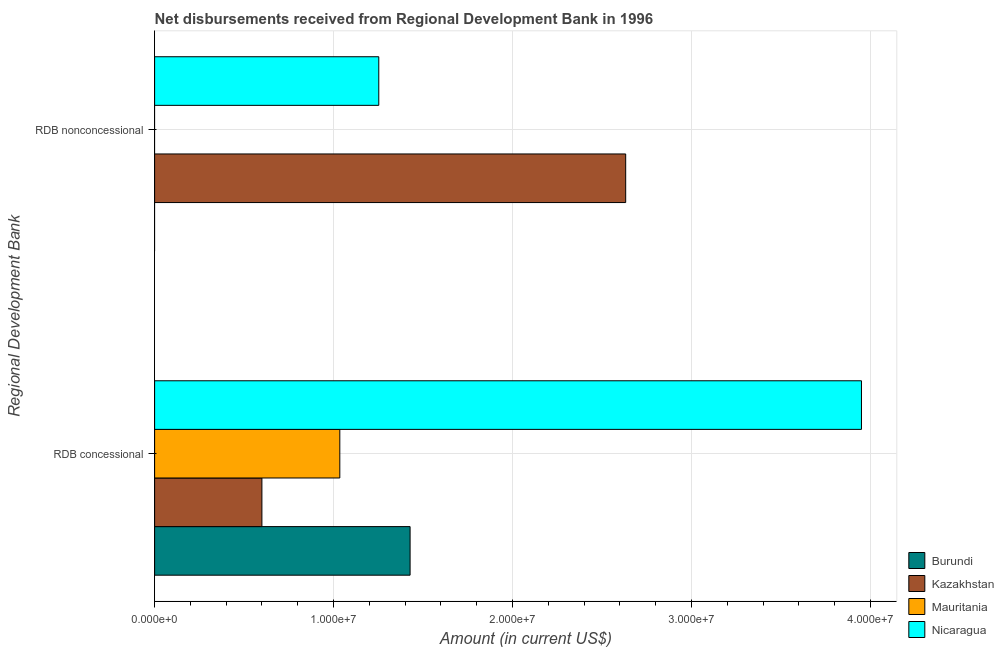How many different coloured bars are there?
Offer a terse response. 4. Are the number of bars on each tick of the Y-axis equal?
Your answer should be very brief. No. What is the label of the 2nd group of bars from the top?
Give a very brief answer. RDB concessional. What is the net concessional disbursements from rdb in Nicaragua?
Give a very brief answer. 3.95e+07. Across all countries, what is the maximum net non concessional disbursements from rdb?
Your answer should be very brief. 2.63e+07. In which country was the net non concessional disbursements from rdb maximum?
Offer a very short reply. Kazakhstan. What is the total net concessional disbursements from rdb in the graph?
Provide a succinct answer. 7.01e+07. What is the difference between the net concessional disbursements from rdb in Kazakhstan and that in Mauritania?
Offer a terse response. -4.35e+06. What is the difference between the net concessional disbursements from rdb in Mauritania and the net non concessional disbursements from rdb in Nicaragua?
Your response must be concise. -2.18e+06. What is the average net non concessional disbursements from rdb per country?
Your response must be concise. 9.71e+06. What is the difference between the net non concessional disbursements from rdb and net concessional disbursements from rdb in Nicaragua?
Make the answer very short. -2.70e+07. What is the ratio of the net concessional disbursements from rdb in Nicaragua to that in Burundi?
Your answer should be compact. 2.77. Are all the bars in the graph horizontal?
Ensure brevity in your answer.  Yes. How many countries are there in the graph?
Provide a succinct answer. 4. What is the difference between two consecutive major ticks on the X-axis?
Your answer should be very brief. 1.00e+07. Are the values on the major ticks of X-axis written in scientific E-notation?
Your response must be concise. Yes. Does the graph contain grids?
Provide a short and direct response. Yes. How many legend labels are there?
Keep it short and to the point. 4. How are the legend labels stacked?
Provide a succinct answer. Vertical. What is the title of the graph?
Your answer should be very brief. Net disbursements received from Regional Development Bank in 1996. What is the label or title of the Y-axis?
Your response must be concise. Regional Development Bank. What is the Amount (in current US$) of Burundi in RDB concessional?
Make the answer very short. 1.43e+07. What is the Amount (in current US$) of Kazakhstan in RDB concessional?
Keep it short and to the point. 6.00e+06. What is the Amount (in current US$) of Mauritania in RDB concessional?
Provide a short and direct response. 1.04e+07. What is the Amount (in current US$) of Nicaragua in RDB concessional?
Your answer should be very brief. 3.95e+07. What is the Amount (in current US$) in Burundi in RDB nonconcessional?
Your answer should be very brief. 0. What is the Amount (in current US$) of Kazakhstan in RDB nonconcessional?
Offer a terse response. 2.63e+07. What is the Amount (in current US$) in Nicaragua in RDB nonconcessional?
Ensure brevity in your answer.  1.25e+07. Across all Regional Development Bank, what is the maximum Amount (in current US$) of Burundi?
Provide a succinct answer. 1.43e+07. Across all Regional Development Bank, what is the maximum Amount (in current US$) in Kazakhstan?
Your response must be concise. 2.63e+07. Across all Regional Development Bank, what is the maximum Amount (in current US$) in Mauritania?
Your response must be concise. 1.04e+07. Across all Regional Development Bank, what is the maximum Amount (in current US$) in Nicaragua?
Offer a very short reply. 3.95e+07. Across all Regional Development Bank, what is the minimum Amount (in current US$) in Burundi?
Your answer should be compact. 0. Across all Regional Development Bank, what is the minimum Amount (in current US$) of Kazakhstan?
Provide a short and direct response. 6.00e+06. Across all Regional Development Bank, what is the minimum Amount (in current US$) in Mauritania?
Offer a very short reply. 0. Across all Regional Development Bank, what is the minimum Amount (in current US$) of Nicaragua?
Offer a terse response. 1.25e+07. What is the total Amount (in current US$) of Burundi in the graph?
Offer a very short reply. 1.43e+07. What is the total Amount (in current US$) in Kazakhstan in the graph?
Your answer should be very brief. 3.23e+07. What is the total Amount (in current US$) of Mauritania in the graph?
Your answer should be compact. 1.04e+07. What is the total Amount (in current US$) of Nicaragua in the graph?
Give a very brief answer. 5.20e+07. What is the difference between the Amount (in current US$) in Kazakhstan in RDB concessional and that in RDB nonconcessional?
Offer a very short reply. -2.03e+07. What is the difference between the Amount (in current US$) of Nicaragua in RDB concessional and that in RDB nonconcessional?
Ensure brevity in your answer.  2.70e+07. What is the difference between the Amount (in current US$) of Burundi in RDB concessional and the Amount (in current US$) of Kazakhstan in RDB nonconcessional?
Ensure brevity in your answer.  -1.20e+07. What is the difference between the Amount (in current US$) of Burundi in RDB concessional and the Amount (in current US$) of Nicaragua in RDB nonconcessional?
Make the answer very short. 1.75e+06. What is the difference between the Amount (in current US$) of Kazakhstan in RDB concessional and the Amount (in current US$) of Nicaragua in RDB nonconcessional?
Offer a very short reply. -6.53e+06. What is the difference between the Amount (in current US$) of Mauritania in RDB concessional and the Amount (in current US$) of Nicaragua in RDB nonconcessional?
Provide a short and direct response. -2.18e+06. What is the average Amount (in current US$) of Burundi per Regional Development Bank?
Your answer should be compact. 7.14e+06. What is the average Amount (in current US$) in Kazakhstan per Regional Development Bank?
Your answer should be compact. 1.62e+07. What is the average Amount (in current US$) in Mauritania per Regional Development Bank?
Offer a very short reply. 5.18e+06. What is the average Amount (in current US$) in Nicaragua per Regional Development Bank?
Provide a succinct answer. 2.60e+07. What is the difference between the Amount (in current US$) of Burundi and Amount (in current US$) of Kazakhstan in RDB concessional?
Provide a succinct answer. 8.28e+06. What is the difference between the Amount (in current US$) of Burundi and Amount (in current US$) of Mauritania in RDB concessional?
Your response must be concise. 3.93e+06. What is the difference between the Amount (in current US$) of Burundi and Amount (in current US$) of Nicaragua in RDB concessional?
Make the answer very short. -2.52e+07. What is the difference between the Amount (in current US$) in Kazakhstan and Amount (in current US$) in Mauritania in RDB concessional?
Keep it short and to the point. -4.35e+06. What is the difference between the Amount (in current US$) of Kazakhstan and Amount (in current US$) of Nicaragua in RDB concessional?
Offer a terse response. -3.35e+07. What is the difference between the Amount (in current US$) of Mauritania and Amount (in current US$) of Nicaragua in RDB concessional?
Provide a short and direct response. -2.92e+07. What is the difference between the Amount (in current US$) of Kazakhstan and Amount (in current US$) of Nicaragua in RDB nonconcessional?
Give a very brief answer. 1.38e+07. What is the ratio of the Amount (in current US$) in Kazakhstan in RDB concessional to that in RDB nonconcessional?
Make the answer very short. 0.23. What is the ratio of the Amount (in current US$) in Nicaragua in RDB concessional to that in RDB nonconcessional?
Provide a succinct answer. 3.15. What is the difference between the highest and the second highest Amount (in current US$) of Kazakhstan?
Give a very brief answer. 2.03e+07. What is the difference between the highest and the second highest Amount (in current US$) in Nicaragua?
Your response must be concise. 2.70e+07. What is the difference between the highest and the lowest Amount (in current US$) of Burundi?
Provide a succinct answer. 1.43e+07. What is the difference between the highest and the lowest Amount (in current US$) of Kazakhstan?
Provide a short and direct response. 2.03e+07. What is the difference between the highest and the lowest Amount (in current US$) of Mauritania?
Give a very brief answer. 1.04e+07. What is the difference between the highest and the lowest Amount (in current US$) of Nicaragua?
Offer a terse response. 2.70e+07. 